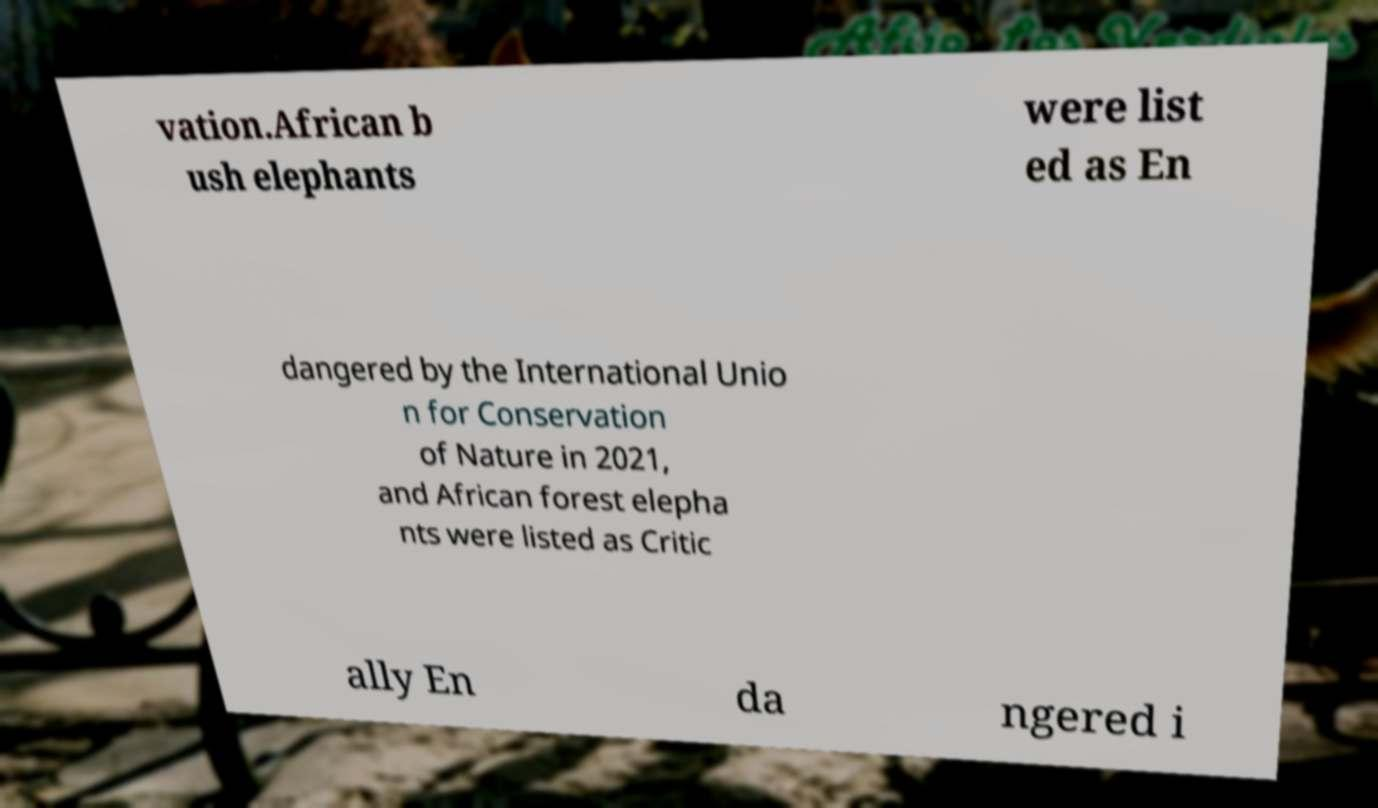Could you extract and type out the text from this image? vation.African b ush elephants were list ed as En dangered by the International Unio n for Conservation of Nature in 2021, and African forest elepha nts were listed as Critic ally En da ngered i 